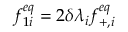<formula> <loc_0><loc_0><loc_500><loc_500>f _ { 1 i } ^ { e q } = 2 \delta \lambda _ { i } f _ { + , i } ^ { e q }</formula> 